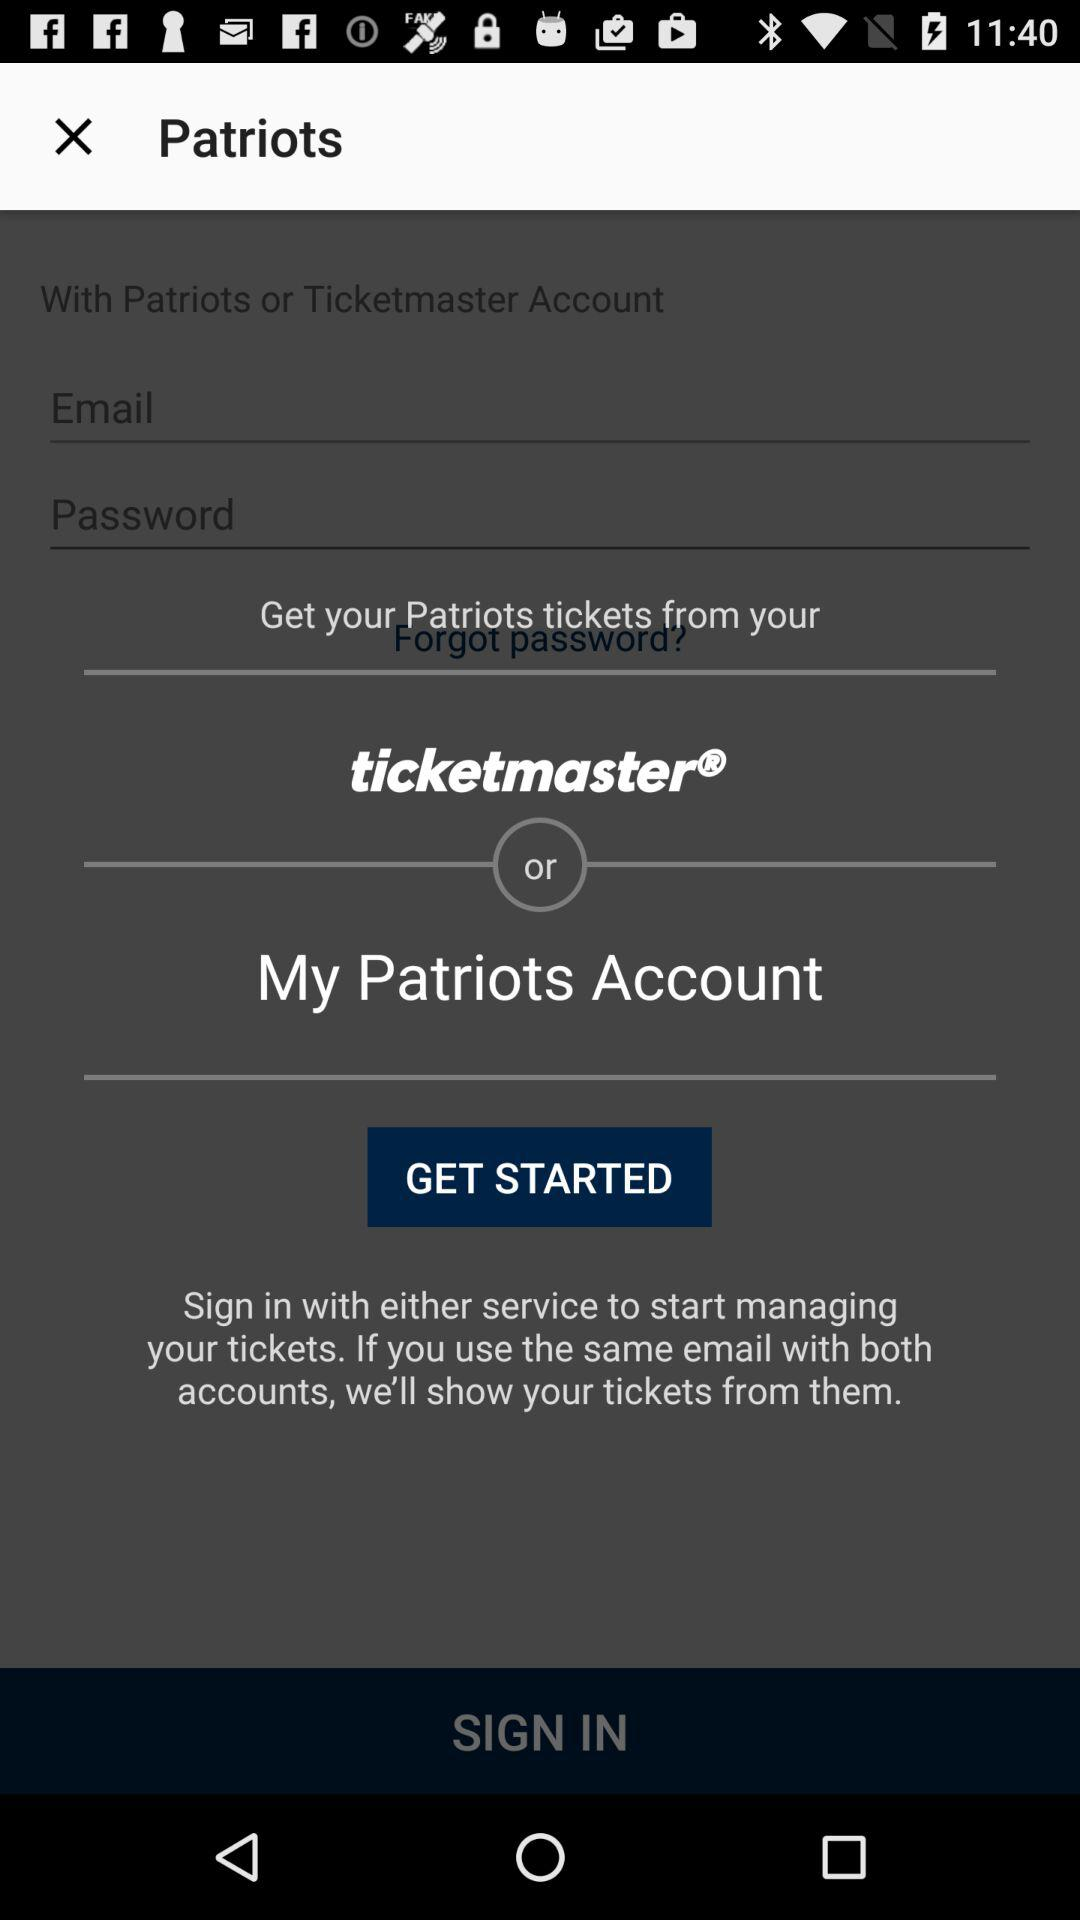Where can we get "Patriots" tickets? You can get the tickets from "ticketmaster" and "Patriots" accounts. 